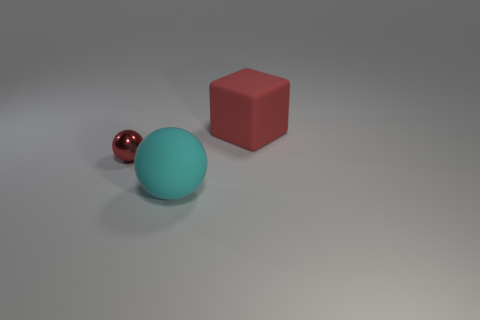Add 1 red metallic spheres. How many objects exist? 4 Subtract all red balls. How many balls are left? 1 Subtract all yellow spheres. How many brown cubes are left? 0 Subtract all large red rubber blocks. Subtract all tiny purple metallic cylinders. How many objects are left? 2 Add 3 tiny metal spheres. How many tiny metal spheres are left? 4 Add 2 large red rubber objects. How many large red rubber objects exist? 3 Subtract 0 cyan cylinders. How many objects are left? 3 Subtract all blocks. How many objects are left? 2 Subtract all gray blocks. Subtract all yellow balls. How many blocks are left? 1 